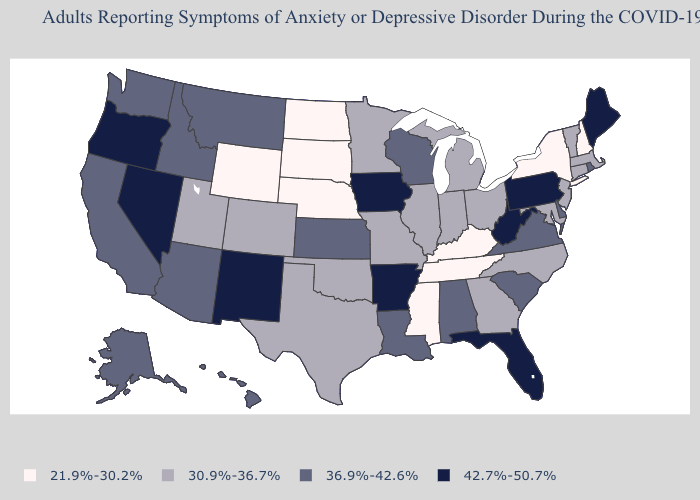What is the lowest value in the South?
Concise answer only. 21.9%-30.2%. Does Georgia have the highest value in the South?
Quick response, please. No. Is the legend a continuous bar?
Concise answer only. No. What is the lowest value in the USA?
Short answer required. 21.9%-30.2%. Name the states that have a value in the range 21.9%-30.2%?
Short answer required. Kentucky, Mississippi, Nebraska, New Hampshire, New York, North Dakota, South Dakota, Tennessee, Wyoming. What is the value of Massachusetts?
Short answer required. 30.9%-36.7%. Does New York have the lowest value in the Northeast?
Keep it brief. Yes. What is the value of Colorado?
Answer briefly. 30.9%-36.7%. Among the states that border Delaware , which have the lowest value?
Concise answer only. Maryland, New Jersey. What is the value of Alabama?
Give a very brief answer. 36.9%-42.6%. Among the states that border Georgia , does South Carolina have the highest value?
Keep it brief. No. Which states hav the highest value in the MidWest?
Keep it brief. Iowa. Does New Hampshire have the lowest value in the Northeast?
Quick response, please. Yes. What is the highest value in states that border North Carolina?
Be succinct. 36.9%-42.6%. Among the states that border Idaho , does Oregon have the lowest value?
Be succinct. No. 